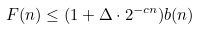Convert formula to latex. <formula><loc_0><loc_0><loc_500><loc_500>F ( n ) \leq ( 1 + \Delta \cdot 2 ^ { - c n } ) b ( n )</formula> 